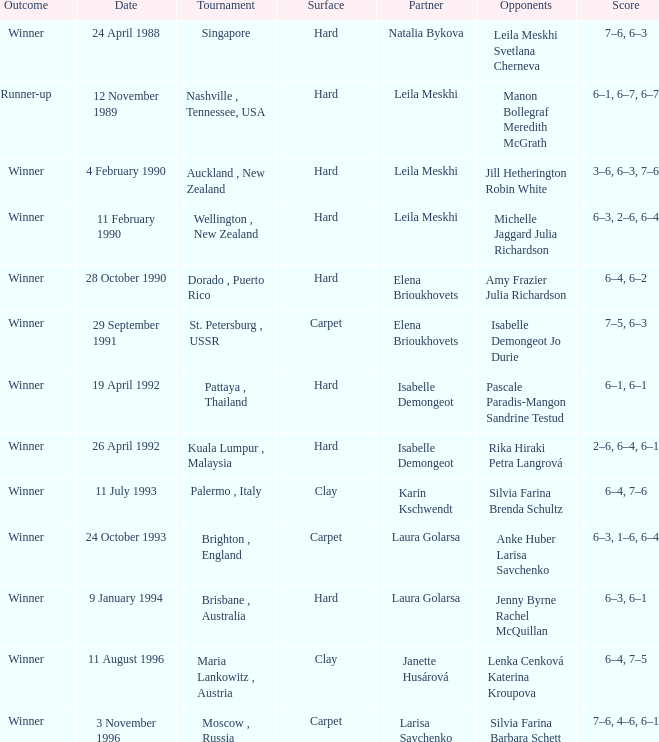On a hard surface, which tournament featured a match with the result 3-6, 6-3, 7-6? Auckland , New Zealand. 